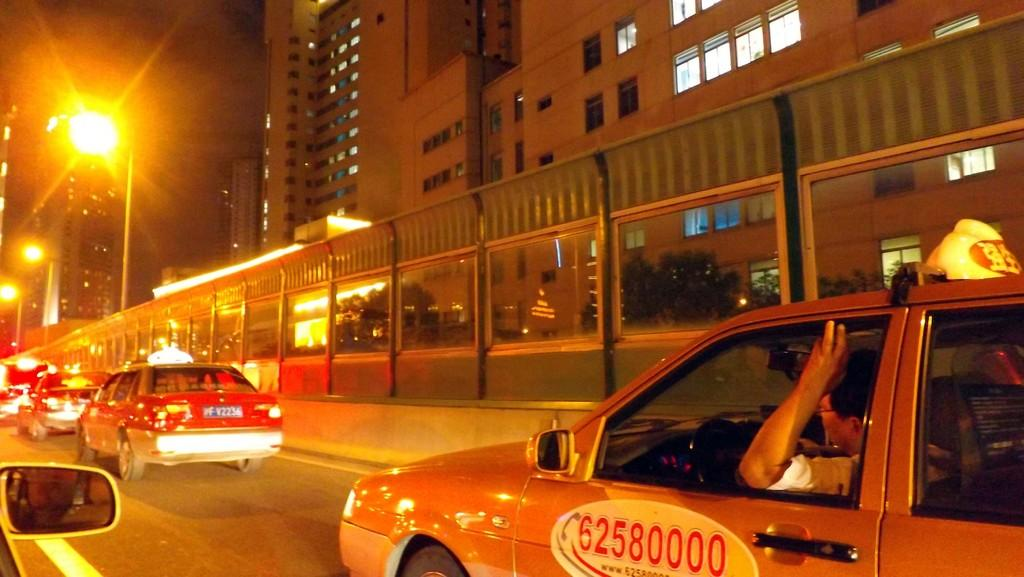<image>
Present a compact description of the photo's key features. A car with an image of a phone next to the numbers 62580000, is stuck in traffic at night. 